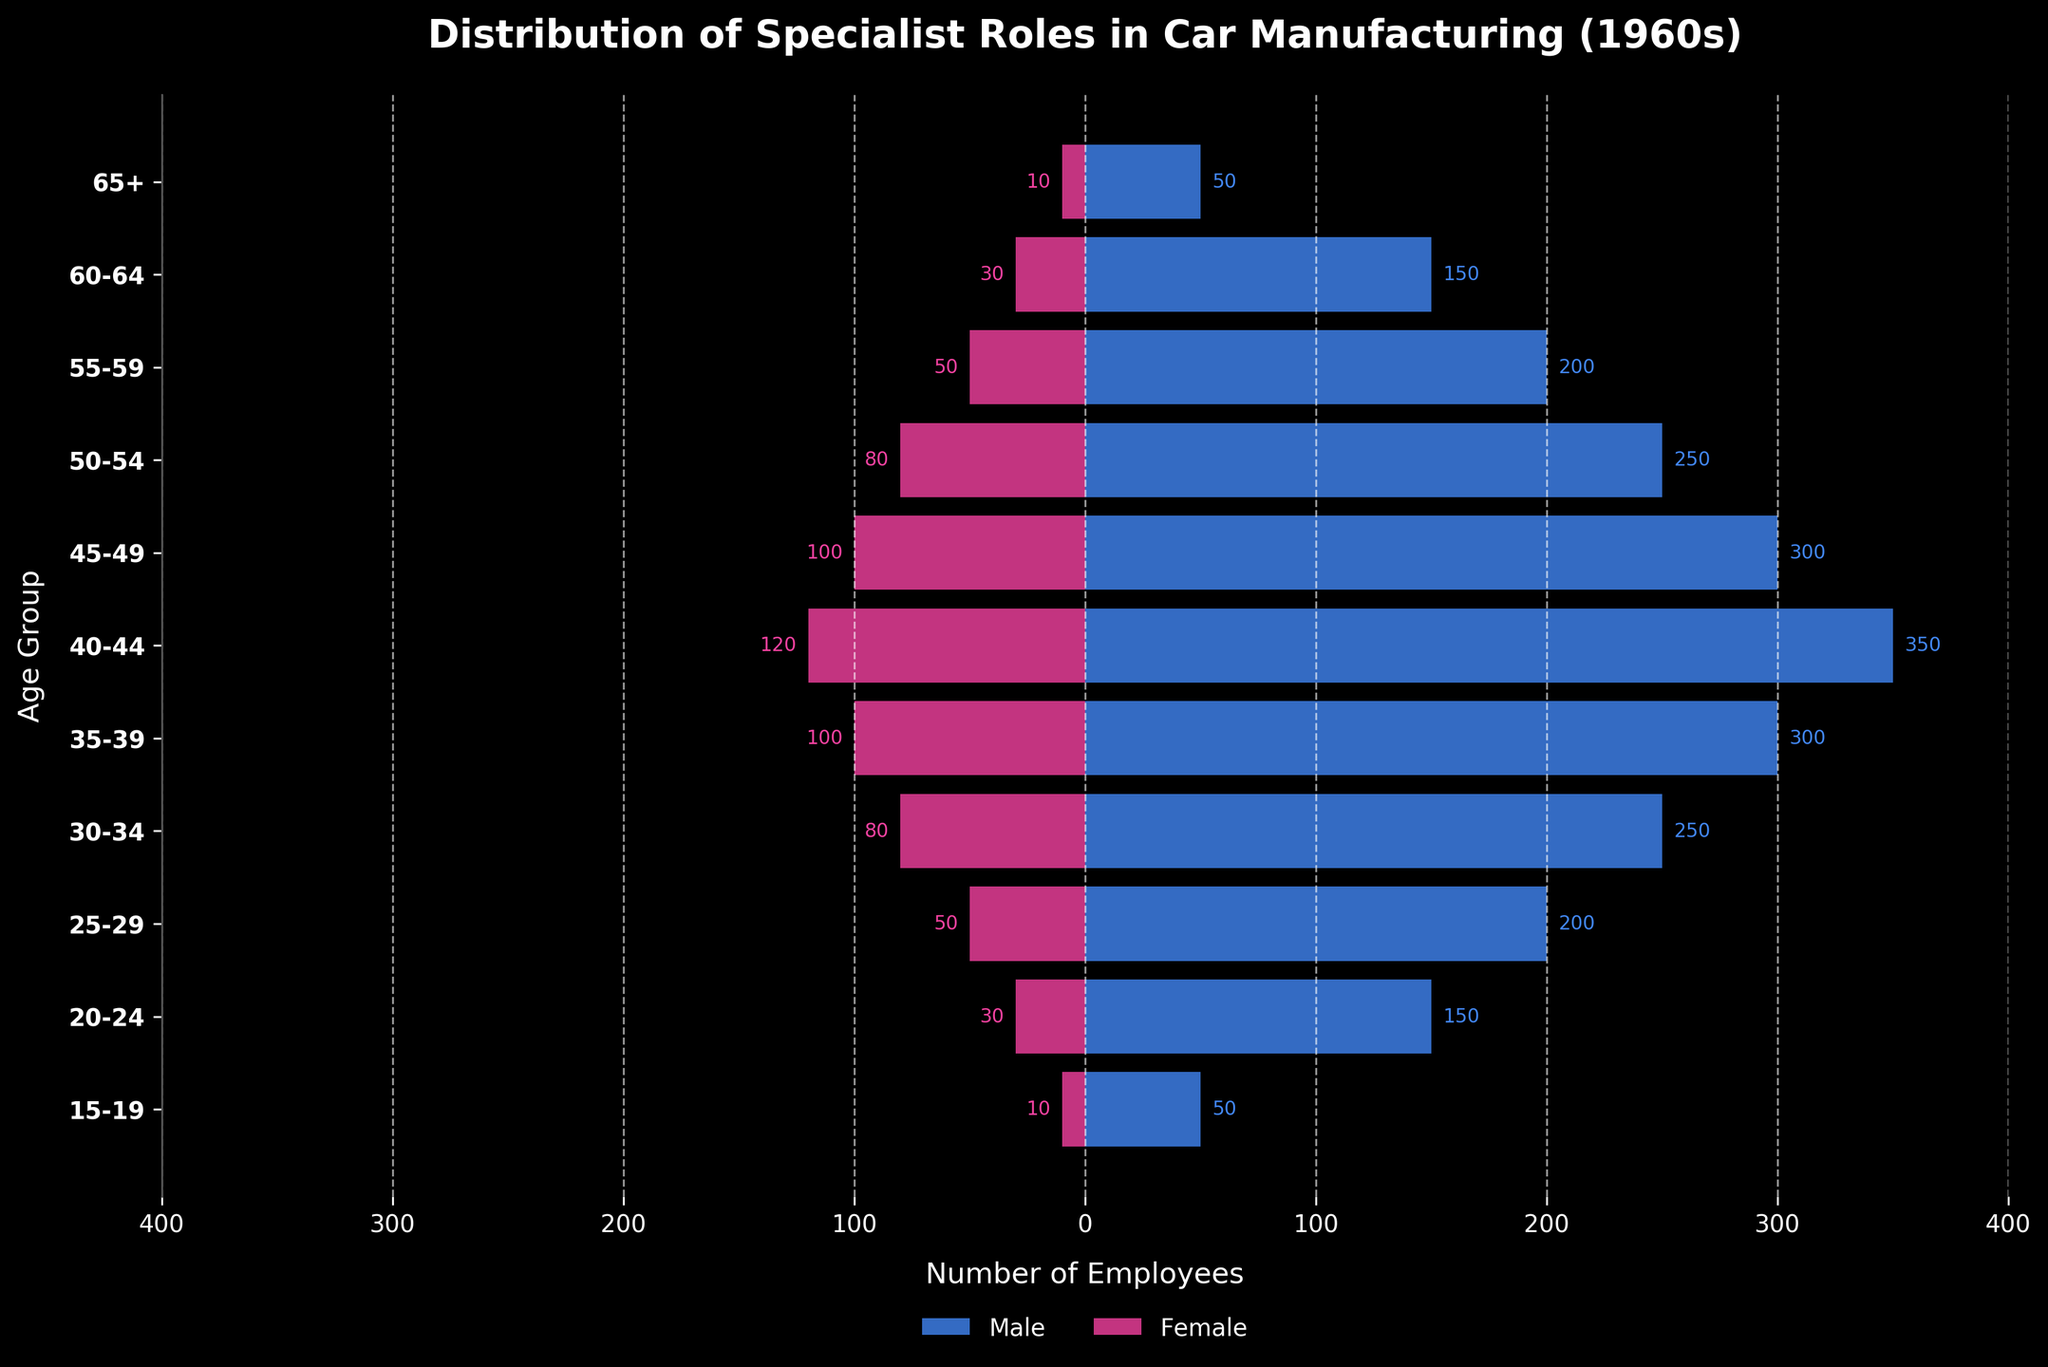What is the title of the plot? The title is displayed at the top of the plot: "Distribution of Specialist Roles in Car Manufacturing (1960s)"
Answer: Distribution of Specialist Roles in Car Manufacturing (1960s) What are the colors representing males and females in the plot? The color for males is blue, and the color for females is pink.
Answer: Blue for males, pink for females Which age group has the highest number of male employees? By looking at the longest blue bar, the age group 40-44 has the highest number with 350 male employees.
Answer: 40-44 What is the total number of female employees in the 20-24 and 25-29 age groups? Adding the values for females in the 20-24 and 25-29 age groups: 30 + 50 = 80.
Answer: 80 In which age group is the number of female employees equal to the number of male employees? None of the age groups has equal numbers of male and female employees when visually inspecting the lengths of the pink and blue bars.
Answer: None How many more males are there than females in the 40-44 age group? Subtract the number of females from males in the 40-44 group: 350 - 120 = 230.
Answer: 230 What is the sum of male employees in the age groups 30-34, 35-39, and 40-44? Adding the values: 250 + 300 + 350 = 900.
Answer: 900 Which age group has the smallest difference in the number of male and female employees? The 15-19 age group has a difference of 40 (50 males - 10 females), which is smaller than any other group.
Answer: 15-19 Which age group has the highest total number of employees (males and females combined)? Adding males and females for each group, the highest total is in the 40-44 group with 350 + 120 = 470.
Answer: 40-44 What is the median number of male employees across all age groups? Listing the numbers and finding the middle value in the sorted list: 50, 150, 150, 200, 200, 250, 250, 300, 300, 350. The median is between 250 and 250, which is 250.
Answer: 250 